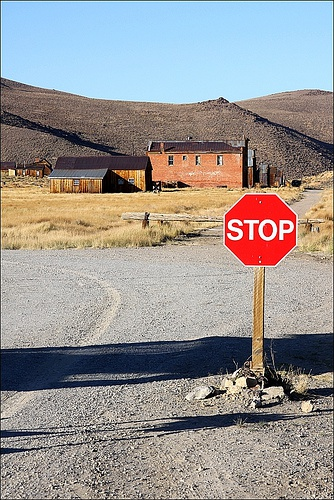Describe the objects in this image and their specific colors. I can see a stop sign in black, red, white, lightpink, and salmon tones in this image. 